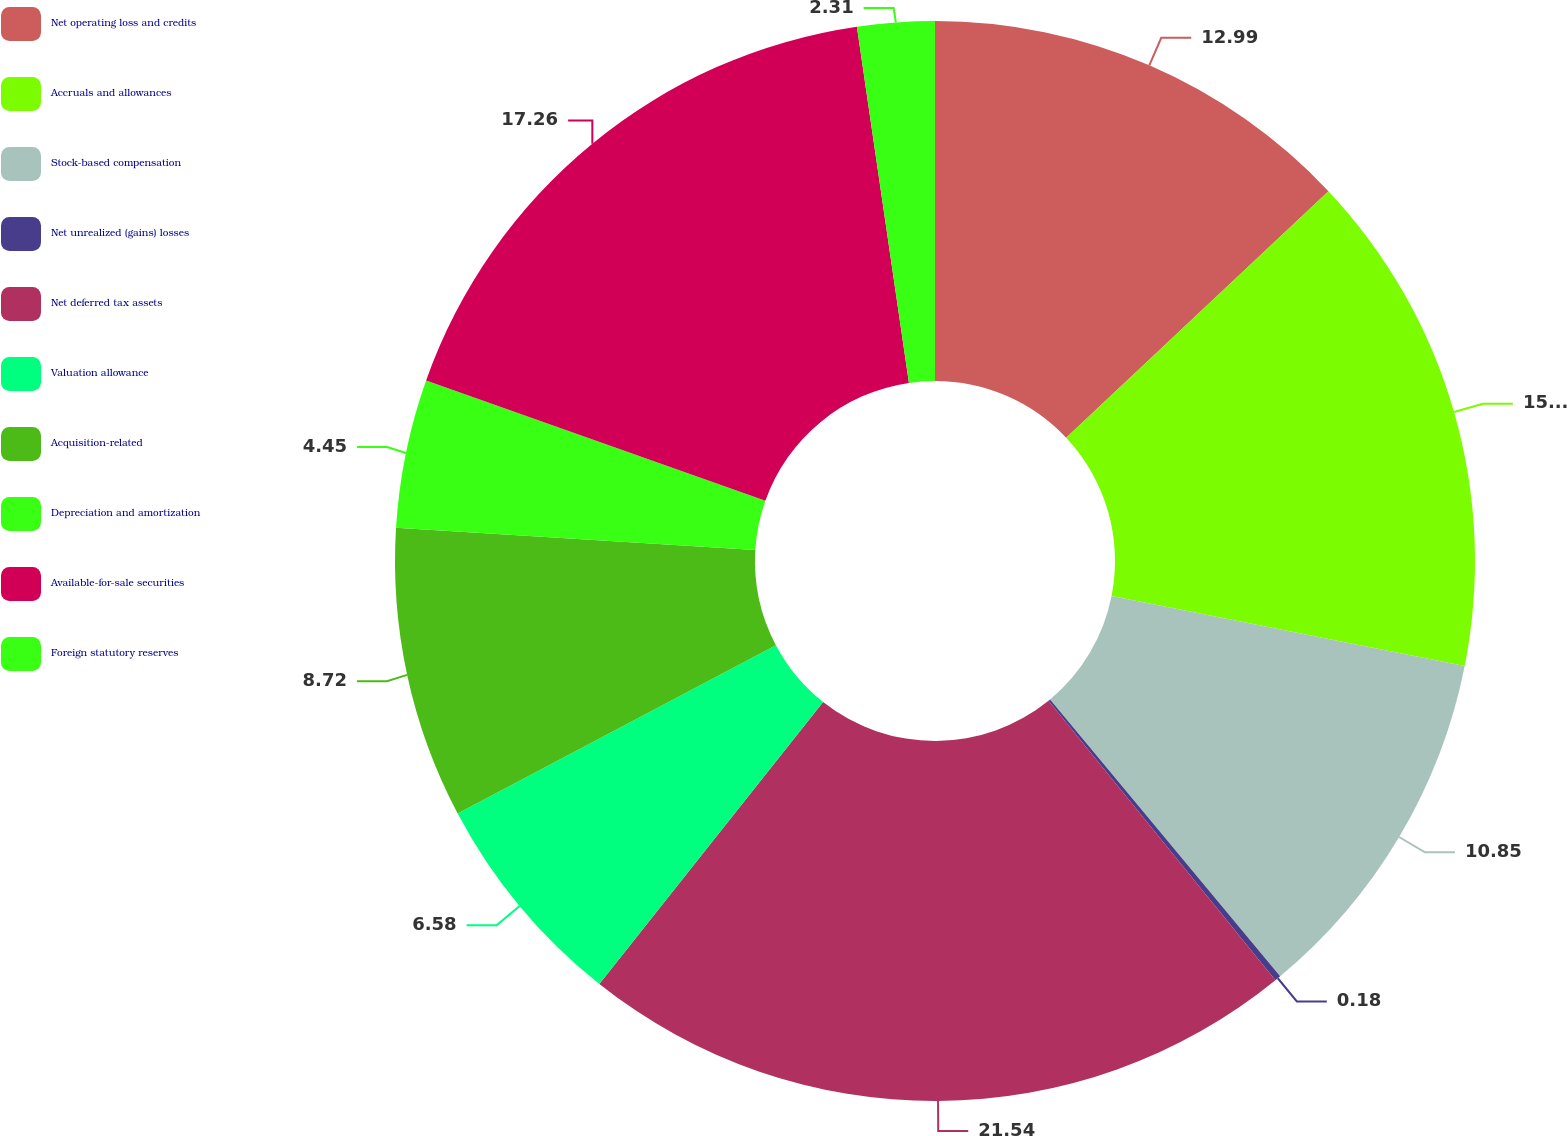Convert chart to OTSL. <chart><loc_0><loc_0><loc_500><loc_500><pie_chart><fcel>Net operating loss and credits<fcel>Accruals and allowances<fcel>Stock-based compensation<fcel>Net unrealized (gains) losses<fcel>Net deferred tax assets<fcel>Valuation allowance<fcel>Acquisition-related<fcel>Depreciation and amortization<fcel>Available-for-sale securities<fcel>Foreign statutory reserves<nl><fcel>12.99%<fcel>15.12%<fcel>10.85%<fcel>0.18%<fcel>21.53%<fcel>6.58%<fcel>8.72%<fcel>4.45%<fcel>17.26%<fcel>2.31%<nl></chart> 